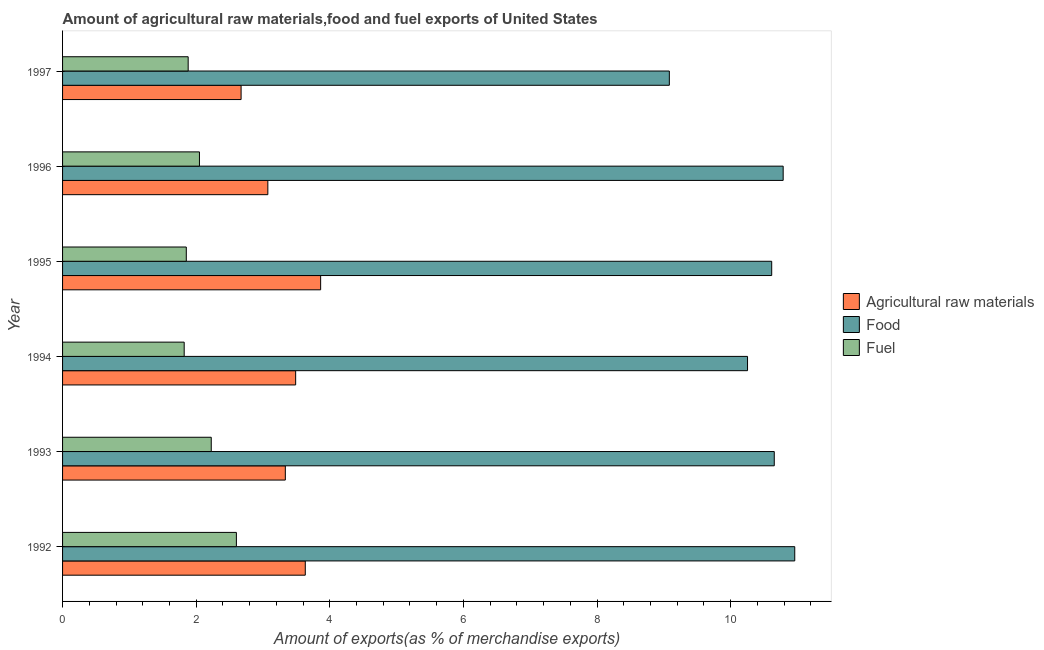How many different coloured bars are there?
Keep it short and to the point. 3. How many bars are there on the 6th tick from the bottom?
Your answer should be compact. 3. What is the percentage of food exports in 1995?
Your response must be concise. 10.61. Across all years, what is the maximum percentage of food exports?
Offer a very short reply. 10.96. Across all years, what is the minimum percentage of food exports?
Keep it short and to the point. 9.08. In which year was the percentage of fuel exports minimum?
Provide a short and direct response. 1994. What is the total percentage of food exports in the graph?
Offer a terse response. 62.35. What is the difference between the percentage of raw materials exports in 1996 and that in 1997?
Make the answer very short. 0.4. What is the difference between the percentage of fuel exports in 1997 and the percentage of raw materials exports in 1992?
Your answer should be very brief. -1.75. What is the average percentage of fuel exports per year?
Give a very brief answer. 2.07. In the year 1994, what is the difference between the percentage of raw materials exports and percentage of food exports?
Make the answer very short. -6.76. What is the ratio of the percentage of fuel exports in 1994 to that in 1996?
Your answer should be compact. 0.89. What is the difference between the highest and the second highest percentage of food exports?
Provide a short and direct response. 0.17. What is the difference between the highest and the lowest percentage of fuel exports?
Provide a succinct answer. 0.78. What does the 2nd bar from the top in 1995 represents?
Ensure brevity in your answer.  Food. What does the 2nd bar from the bottom in 1997 represents?
Offer a terse response. Food. How many years are there in the graph?
Your answer should be compact. 6. Are the values on the major ticks of X-axis written in scientific E-notation?
Offer a terse response. No. Does the graph contain any zero values?
Give a very brief answer. No. How many legend labels are there?
Make the answer very short. 3. What is the title of the graph?
Offer a terse response. Amount of agricultural raw materials,food and fuel exports of United States. What is the label or title of the X-axis?
Your answer should be compact. Amount of exports(as % of merchandise exports). What is the label or title of the Y-axis?
Ensure brevity in your answer.  Year. What is the Amount of exports(as % of merchandise exports) in Agricultural raw materials in 1992?
Your response must be concise. 3.63. What is the Amount of exports(as % of merchandise exports) in Food in 1992?
Keep it short and to the point. 10.96. What is the Amount of exports(as % of merchandise exports) in Fuel in 1992?
Your response must be concise. 2.6. What is the Amount of exports(as % of merchandise exports) in Agricultural raw materials in 1993?
Your response must be concise. 3.33. What is the Amount of exports(as % of merchandise exports) of Food in 1993?
Provide a succinct answer. 10.65. What is the Amount of exports(as % of merchandise exports) of Fuel in 1993?
Your response must be concise. 2.23. What is the Amount of exports(as % of merchandise exports) of Agricultural raw materials in 1994?
Provide a short and direct response. 3.49. What is the Amount of exports(as % of merchandise exports) of Food in 1994?
Provide a succinct answer. 10.25. What is the Amount of exports(as % of merchandise exports) of Fuel in 1994?
Give a very brief answer. 1.82. What is the Amount of exports(as % of merchandise exports) in Agricultural raw materials in 1995?
Your response must be concise. 3.86. What is the Amount of exports(as % of merchandise exports) in Food in 1995?
Give a very brief answer. 10.61. What is the Amount of exports(as % of merchandise exports) of Fuel in 1995?
Provide a short and direct response. 1.85. What is the Amount of exports(as % of merchandise exports) of Agricultural raw materials in 1996?
Your answer should be compact. 3.07. What is the Amount of exports(as % of merchandise exports) of Food in 1996?
Your answer should be compact. 10.79. What is the Amount of exports(as % of merchandise exports) of Fuel in 1996?
Offer a very short reply. 2.05. What is the Amount of exports(as % of merchandise exports) of Agricultural raw materials in 1997?
Your answer should be compact. 2.67. What is the Amount of exports(as % of merchandise exports) in Food in 1997?
Your answer should be very brief. 9.08. What is the Amount of exports(as % of merchandise exports) of Fuel in 1997?
Your answer should be very brief. 1.88. Across all years, what is the maximum Amount of exports(as % of merchandise exports) of Agricultural raw materials?
Offer a terse response. 3.86. Across all years, what is the maximum Amount of exports(as % of merchandise exports) in Food?
Make the answer very short. 10.96. Across all years, what is the maximum Amount of exports(as % of merchandise exports) of Fuel?
Provide a succinct answer. 2.6. Across all years, what is the minimum Amount of exports(as % of merchandise exports) of Agricultural raw materials?
Your answer should be very brief. 2.67. Across all years, what is the minimum Amount of exports(as % of merchandise exports) in Food?
Your answer should be very brief. 9.08. Across all years, what is the minimum Amount of exports(as % of merchandise exports) in Fuel?
Your answer should be compact. 1.82. What is the total Amount of exports(as % of merchandise exports) of Agricultural raw materials in the graph?
Give a very brief answer. 20.06. What is the total Amount of exports(as % of merchandise exports) of Food in the graph?
Offer a very short reply. 62.35. What is the total Amount of exports(as % of merchandise exports) in Fuel in the graph?
Your answer should be compact. 12.43. What is the difference between the Amount of exports(as % of merchandise exports) of Agricultural raw materials in 1992 and that in 1993?
Provide a short and direct response. 0.3. What is the difference between the Amount of exports(as % of merchandise exports) of Food in 1992 and that in 1993?
Keep it short and to the point. 0.31. What is the difference between the Amount of exports(as % of merchandise exports) of Fuel in 1992 and that in 1993?
Your answer should be very brief. 0.38. What is the difference between the Amount of exports(as % of merchandise exports) of Agricultural raw materials in 1992 and that in 1994?
Make the answer very short. 0.14. What is the difference between the Amount of exports(as % of merchandise exports) of Food in 1992 and that in 1994?
Your response must be concise. 0.71. What is the difference between the Amount of exports(as % of merchandise exports) in Fuel in 1992 and that in 1994?
Provide a succinct answer. 0.78. What is the difference between the Amount of exports(as % of merchandise exports) of Agricultural raw materials in 1992 and that in 1995?
Make the answer very short. -0.23. What is the difference between the Amount of exports(as % of merchandise exports) in Food in 1992 and that in 1995?
Give a very brief answer. 0.34. What is the difference between the Amount of exports(as % of merchandise exports) of Fuel in 1992 and that in 1995?
Offer a terse response. 0.75. What is the difference between the Amount of exports(as % of merchandise exports) in Agricultural raw materials in 1992 and that in 1996?
Provide a succinct answer. 0.56. What is the difference between the Amount of exports(as % of merchandise exports) of Food in 1992 and that in 1996?
Offer a terse response. 0.17. What is the difference between the Amount of exports(as % of merchandise exports) of Fuel in 1992 and that in 1996?
Ensure brevity in your answer.  0.55. What is the difference between the Amount of exports(as % of merchandise exports) of Agricultural raw materials in 1992 and that in 1997?
Your answer should be very brief. 0.96. What is the difference between the Amount of exports(as % of merchandise exports) in Food in 1992 and that in 1997?
Make the answer very short. 1.88. What is the difference between the Amount of exports(as % of merchandise exports) of Fuel in 1992 and that in 1997?
Give a very brief answer. 0.72. What is the difference between the Amount of exports(as % of merchandise exports) of Agricultural raw materials in 1993 and that in 1994?
Offer a very short reply. -0.15. What is the difference between the Amount of exports(as % of merchandise exports) in Food in 1993 and that in 1994?
Your answer should be compact. 0.4. What is the difference between the Amount of exports(as % of merchandise exports) in Fuel in 1993 and that in 1994?
Offer a terse response. 0.41. What is the difference between the Amount of exports(as % of merchandise exports) in Agricultural raw materials in 1993 and that in 1995?
Your response must be concise. -0.53. What is the difference between the Amount of exports(as % of merchandise exports) in Food in 1993 and that in 1995?
Make the answer very short. 0.04. What is the difference between the Amount of exports(as % of merchandise exports) in Fuel in 1993 and that in 1995?
Provide a short and direct response. 0.37. What is the difference between the Amount of exports(as % of merchandise exports) of Agricultural raw materials in 1993 and that in 1996?
Your answer should be very brief. 0.26. What is the difference between the Amount of exports(as % of merchandise exports) in Food in 1993 and that in 1996?
Keep it short and to the point. -0.13. What is the difference between the Amount of exports(as % of merchandise exports) of Fuel in 1993 and that in 1996?
Provide a succinct answer. 0.18. What is the difference between the Amount of exports(as % of merchandise exports) of Agricultural raw materials in 1993 and that in 1997?
Keep it short and to the point. 0.66. What is the difference between the Amount of exports(as % of merchandise exports) in Food in 1993 and that in 1997?
Provide a succinct answer. 1.57. What is the difference between the Amount of exports(as % of merchandise exports) in Fuel in 1993 and that in 1997?
Your answer should be very brief. 0.35. What is the difference between the Amount of exports(as % of merchandise exports) in Agricultural raw materials in 1994 and that in 1995?
Keep it short and to the point. -0.37. What is the difference between the Amount of exports(as % of merchandise exports) of Food in 1994 and that in 1995?
Offer a terse response. -0.36. What is the difference between the Amount of exports(as % of merchandise exports) in Fuel in 1994 and that in 1995?
Keep it short and to the point. -0.03. What is the difference between the Amount of exports(as % of merchandise exports) in Agricultural raw materials in 1994 and that in 1996?
Your answer should be compact. 0.42. What is the difference between the Amount of exports(as % of merchandise exports) in Food in 1994 and that in 1996?
Provide a succinct answer. -0.53. What is the difference between the Amount of exports(as % of merchandise exports) in Fuel in 1994 and that in 1996?
Offer a terse response. -0.23. What is the difference between the Amount of exports(as % of merchandise exports) in Agricultural raw materials in 1994 and that in 1997?
Provide a succinct answer. 0.82. What is the difference between the Amount of exports(as % of merchandise exports) of Food in 1994 and that in 1997?
Provide a short and direct response. 1.17. What is the difference between the Amount of exports(as % of merchandise exports) in Fuel in 1994 and that in 1997?
Provide a succinct answer. -0.06. What is the difference between the Amount of exports(as % of merchandise exports) of Agricultural raw materials in 1995 and that in 1996?
Give a very brief answer. 0.79. What is the difference between the Amount of exports(as % of merchandise exports) of Food in 1995 and that in 1996?
Your answer should be very brief. -0.17. What is the difference between the Amount of exports(as % of merchandise exports) in Fuel in 1995 and that in 1996?
Your answer should be very brief. -0.2. What is the difference between the Amount of exports(as % of merchandise exports) in Agricultural raw materials in 1995 and that in 1997?
Your answer should be compact. 1.19. What is the difference between the Amount of exports(as % of merchandise exports) in Food in 1995 and that in 1997?
Your answer should be very brief. 1.53. What is the difference between the Amount of exports(as % of merchandise exports) in Fuel in 1995 and that in 1997?
Offer a very short reply. -0.03. What is the difference between the Amount of exports(as % of merchandise exports) in Agricultural raw materials in 1996 and that in 1997?
Your answer should be very brief. 0.4. What is the difference between the Amount of exports(as % of merchandise exports) in Food in 1996 and that in 1997?
Offer a terse response. 1.7. What is the difference between the Amount of exports(as % of merchandise exports) of Fuel in 1996 and that in 1997?
Provide a succinct answer. 0.17. What is the difference between the Amount of exports(as % of merchandise exports) in Agricultural raw materials in 1992 and the Amount of exports(as % of merchandise exports) in Food in 1993?
Ensure brevity in your answer.  -7.02. What is the difference between the Amount of exports(as % of merchandise exports) of Agricultural raw materials in 1992 and the Amount of exports(as % of merchandise exports) of Fuel in 1993?
Your answer should be compact. 1.41. What is the difference between the Amount of exports(as % of merchandise exports) of Food in 1992 and the Amount of exports(as % of merchandise exports) of Fuel in 1993?
Your answer should be very brief. 8.73. What is the difference between the Amount of exports(as % of merchandise exports) of Agricultural raw materials in 1992 and the Amount of exports(as % of merchandise exports) of Food in 1994?
Ensure brevity in your answer.  -6.62. What is the difference between the Amount of exports(as % of merchandise exports) of Agricultural raw materials in 1992 and the Amount of exports(as % of merchandise exports) of Fuel in 1994?
Ensure brevity in your answer.  1.81. What is the difference between the Amount of exports(as % of merchandise exports) in Food in 1992 and the Amount of exports(as % of merchandise exports) in Fuel in 1994?
Offer a very short reply. 9.14. What is the difference between the Amount of exports(as % of merchandise exports) in Agricultural raw materials in 1992 and the Amount of exports(as % of merchandise exports) in Food in 1995?
Make the answer very short. -6.98. What is the difference between the Amount of exports(as % of merchandise exports) in Agricultural raw materials in 1992 and the Amount of exports(as % of merchandise exports) in Fuel in 1995?
Offer a very short reply. 1.78. What is the difference between the Amount of exports(as % of merchandise exports) in Food in 1992 and the Amount of exports(as % of merchandise exports) in Fuel in 1995?
Your answer should be very brief. 9.11. What is the difference between the Amount of exports(as % of merchandise exports) of Agricultural raw materials in 1992 and the Amount of exports(as % of merchandise exports) of Food in 1996?
Provide a short and direct response. -7.15. What is the difference between the Amount of exports(as % of merchandise exports) in Agricultural raw materials in 1992 and the Amount of exports(as % of merchandise exports) in Fuel in 1996?
Your answer should be compact. 1.58. What is the difference between the Amount of exports(as % of merchandise exports) in Food in 1992 and the Amount of exports(as % of merchandise exports) in Fuel in 1996?
Make the answer very short. 8.91. What is the difference between the Amount of exports(as % of merchandise exports) of Agricultural raw materials in 1992 and the Amount of exports(as % of merchandise exports) of Food in 1997?
Your answer should be compact. -5.45. What is the difference between the Amount of exports(as % of merchandise exports) in Agricultural raw materials in 1992 and the Amount of exports(as % of merchandise exports) in Fuel in 1997?
Offer a very short reply. 1.75. What is the difference between the Amount of exports(as % of merchandise exports) in Food in 1992 and the Amount of exports(as % of merchandise exports) in Fuel in 1997?
Provide a succinct answer. 9.08. What is the difference between the Amount of exports(as % of merchandise exports) in Agricultural raw materials in 1993 and the Amount of exports(as % of merchandise exports) in Food in 1994?
Give a very brief answer. -6.92. What is the difference between the Amount of exports(as % of merchandise exports) of Agricultural raw materials in 1993 and the Amount of exports(as % of merchandise exports) of Fuel in 1994?
Make the answer very short. 1.51. What is the difference between the Amount of exports(as % of merchandise exports) of Food in 1993 and the Amount of exports(as % of merchandise exports) of Fuel in 1994?
Give a very brief answer. 8.83. What is the difference between the Amount of exports(as % of merchandise exports) of Agricultural raw materials in 1993 and the Amount of exports(as % of merchandise exports) of Food in 1995?
Ensure brevity in your answer.  -7.28. What is the difference between the Amount of exports(as % of merchandise exports) of Agricultural raw materials in 1993 and the Amount of exports(as % of merchandise exports) of Fuel in 1995?
Provide a short and direct response. 1.48. What is the difference between the Amount of exports(as % of merchandise exports) of Food in 1993 and the Amount of exports(as % of merchandise exports) of Fuel in 1995?
Offer a very short reply. 8.8. What is the difference between the Amount of exports(as % of merchandise exports) in Agricultural raw materials in 1993 and the Amount of exports(as % of merchandise exports) in Food in 1996?
Your response must be concise. -7.45. What is the difference between the Amount of exports(as % of merchandise exports) in Agricultural raw materials in 1993 and the Amount of exports(as % of merchandise exports) in Fuel in 1996?
Offer a terse response. 1.29. What is the difference between the Amount of exports(as % of merchandise exports) of Food in 1993 and the Amount of exports(as % of merchandise exports) of Fuel in 1996?
Your answer should be compact. 8.6. What is the difference between the Amount of exports(as % of merchandise exports) in Agricultural raw materials in 1993 and the Amount of exports(as % of merchandise exports) in Food in 1997?
Provide a succinct answer. -5.75. What is the difference between the Amount of exports(as % of merchandise exports) of Agricultural raw materials in 1993 and the Amount of exports(as % of merchandise exports) of Fuel in 1997?
Offer a terse response. 1.45. What is the difference between the Amount of exports(as % of merchandise exports) in Food in 1993 and the Amount of exports(as % of merchandise exports) in Fuel in 1997?
Make the answer very short. 8.77. What is the difference between the Amount of exports(as % of merchandise exports) in Agricultural raw materials in 1994 and the Amount of exports(as % of merchandise exports) in Food in 1995?
Provide a short and direct response. -7.13. What is the difference between the Amount of exports(as % of merchandise exports) in Agricultural raw materials in 1994 and the Amount of exports(as % of merchandise exports) in Fuel in 1995?
Provide a succinct answer. 1.64. What is the difference between the Amount of exports(as % of merchandise exports) in Food in 1994 and the Amount of exports(as % of merchandise exports) in Fuel in 1995?
Give a very brief answer. 8.4. What is the difference between the Amount of exports(as % of merchandise exports) in Agricultural raw materials in 1994 and the Amount of exports(as % of merchandise exports) in Food in 1996?
Provide a short and direct response. -7.3. What is the difference between the Amount of exports(as % of merchandise exports) of Agricultural raw materials in 1994 and the Amount of exports(as % of merchandise exports) of Fuel in 1996?
Offer a terse response. 1.44. What is the difference between the Amount of exports(as % of merchandise exports) of Food in 1994 and the Amount of exports(as % of merchandise exports) of Fuel in 1996?
Provide a succinct answer. 8.2. What is the difference between the Amount of exports(as % of merchandise exports) in Agricultural raw materials in 1994 and the Amount of exports(as % of merchandise exports) in Food in 1997?
Give a very brief answer. -5.59. What is the difference between the Amount of exports(as % of merchandise exports) in Agricultural raw materials in 1994 and the Amount of exports(as % of merchandise exports) in Fuel in 1997?
Your answer should be compact. 1.61. What is the difference between the Amount of exports(as % of merchandise exports) in Food in 1994 and the Amount of exports(as % of merchandise exports) in Fuel in 1997?
Give a very brief answer. 8.37. What is the difference between the Amount of exports(as % of merchandise exports) of Agricultural raw materials in 1995 and the Amount of exports(as % of merchandise exports) of Food in 1996?
Provide a short and direct response. -6.92. What is the difference between the Amount of exports(as % of merchandise exports) of Agricultural raw materials in 1995 and the Amount of exports(as % of merchandise exports) of Fuel in 1996?
Offer a terse response. 1.81. What is the difference between the Amount of exports(as % of merchandise exports) of Food in 1995 and the Amount of exports(as % of merchandise exports) of Fuel in 1996?
Give a very brief answer. 8.57. What is the difference between the Amount of exports(as % of merchandise exports) of Agricultural raw materials in 1995 and the Amount of exports(as % of merchandise exports) of Food in 1997?
Offer a terse response. -5.22. What is the difference between the Amount of exports(as % of merchandise exports) in Agricultural raw materials in 1995 and the Amount of exports(as % of merchandise exports) in Fuel in 1997?
Give a very brief answer. 1.98. What is the difference between the Amount of exports(as % of merchandise exports) of Food in 1995 and the Amount of exports(as % of merchandise exports) of Fuel in 1997?
Your answer should be compact. 8.73. What is the difference between the Amount of exports(as % of merchandise exports) of Agricultural raw materials in 1996 and the Amount of exports(as % of merchandise exports) of Food in 1997?
Your answer should be compact. -6.01. What is the difference between the Amount of exports(as % of merchandise exports) in Agricultural raw materials in 1996 and the Amount of exports(as % of merchandise exports) in Fuel in 1997?
Keep it short and to the point. 1.19. What is the difference between the Amount of exports(as % of merchandise exports) in Food in 1996 and the Amount of exports(as % of merchandise exports) in Fuel in 1997?
Your answer should be compact. 8.91. What is the average Amount of exports(as % of merchandise exports) in Agricultural raw materials per year?
Ensure brevity in your answer.  3.34. What is the average Amount of exports(as % of merchandise exports) in Food per year?
Keep it short and to the point. 10.39. What is the average Amount of exports(as % of merchandise exports) of Fuel per year?
Offer a terse response. 2.07. In the year 1992, what is the difference between the Amount of exports(as % of merchandise exports) in Agricultural raw materials and Amount of exports(as % of merchandise exports) in Food?
Your answer should be compact. -7.33. In the year 1992, what is the difference between the Amount of exports(as % of merchandise exports) of Agricultural raw materials and Amount of exports(as % of merchandise exports) of Fuel?
Provide a short and direct response. 1.03. In the year 1992, what is the difference between the Amount of exports(as % of merchandise exports) of Food and Amount of exports(as % of merchandise exports) of Fuel?
Your answer should be compact. 8.36. In the year 1993, what is the difference between the Amount of exports(as % of merchandise exports) in Agricultural raw materials and Amount of exports(as % of merchandise exports) in Food?
Your answer should be compact. -7.32. In the year 1993, what is the difference between the Amount of exports(as % of merchandise exports) of Agricultural raw materials and Amount of exports(as % of merchandise exports) of Fuel?
Ensure brevity in your answer.  1.11. In the year 1993, what is the difference between the Amount of exports(as % of merchandise exports) of Food and Amount of exports(as % of merchandise exports) of Fuel?
Give a very brief answer. 8.43. In the year 1994, what is the difference between the Amount of exports(as % of merchandise exports) in Agricultural raw materials and Amount of exports(as % of merchandise exports) in Food?
Offer a terse response. -6.76. In the year 1994, what is the difference between the Amount of exports(as % of merchandise exports) in Agricultural raw materials and Amount of exports(as % of merchandise exports) in Fuel?
Keep it short and to the point. 1.67. In the year 1994, what is the difference between the Amount of exports(as % of merchandise exports) in Food and Amount of exports(as % of merchandise exports) in Fuel?
Make the answer very short. 8.43. In the year 1995, what is the difference between the Amount of exports(as % of merchandise exports) of Agricultural raw materials and Amount of exports(as % of merchandise exports) of Food?
Your response must be concise. -6.75. In the year 1995, what is the difference between the Amount of exports(as % of merchandise exports) of Agricultural raw materials and Amount of exports(as % of merchandise exports) of Fuel?
Offer a very short reply. 2.01. In the year 1995, what is the difference between the Amount of exports(as % of merchandise exports) of Food and Amount of exports(as % of merchandise exports) of Fuel?
Your response must be concise. 8.76. In the year 1996, what is the difference between the Amount of exports(as % of merchandise exports) of Agricultural raw materials and Amount of exports(as % of merchandise exports) of Food?
Provide a succinct answer. -7.71. In the year 1996, what is the difference between the Amount of exports(as % of merchandise exports) of Agricultural raw materials and Amount of exports(as % of merchandise exports) of Fuel?
Your answer should be compact. 1.02. In the year 1996, what is the difference between the Amount of exports(as % of merchandise exports) of Food and Amount of exports(as % of merchandise exports) of Fuel?
Give a very brief answer. 8.74. In the year 1997, what is the difference between the Amount of exports(as % of merchandise exports) in Agricultural raw materials and Amount of exports(as % of merchandise exports) in Food?
Your answer should be compact. -6.41. In the year 1997, what is the difference between the Amount of exports(as % of merchandise exports) of Agricultural raw materials and Amount of exports(as % of merchandise exports) of Fuel?
Provide a short and direct response. 0.79. In the year 1997, what is the difference between the Amount of exports(as % of merchandise exports) in Food and Amount of exports(as % of merchandise exports) in Fuel?
Keep it short and to the point. 7.2. What is the ratio of the Amount of exports(as % of merchandise exports) in Agricultural raw materials in 1992 to that in 1993?
Your answer should be compact. 1.09. What is the ratio of the Amount of exports(as % of merchandise exports) of Food in 1992 to that in 1993?
Your answer should be very brief. 1.03. What is the ratio of the Amount of exports(as % of merchandise exports) in Fuel in 1992 to that in 1993?
Your response must be concise. 1.17. What is the ratio of the Amount of exports(as % of merchandise exports) of Agricultural raw materials in 1992 to that in 1994?
Offer a terse response. 1.04. What is the ratio of the Amount of exports(as % of merchandise exports) in Food in 1992 to that in 1994?
Your answer should be compact. 1.07. What is the ratio of the Amount of exports(as % of merchandise exports) of Fuel in 1992 to that in 1994?
Make the answer very short. 1.43. What is the ratio of the Amount of exports(as % of merchandise exports) of Agricultural raw materials in 1992 to that in 1995?
Your answer should be compact. 0.94. What is the ratio of the Amount of exports(as % of merchandise exports) of Food in 1992 to that in 1995?
Provide a short and direct response. 1.03. What is the ratio of the Amount of exports(as % of merchandise exports) of Fuel in 1992 to that in 1995?
Provide a short and direct response. 1.4. What is the ratio of the Amount of exports(as % of merchandise exports) in Agricultural raw materials in 1992 to that in 1996?
Give a very brief answer. 1.18. What is the ratio of the Amount of exports(as % of merchandise exports) of Food in 1992 to that in 1996?
Offer a terse response. 1.02. What is the ratio of the Amount of exports(as % of merchandise exports) in Fuel in 1992 to that in 1996?
Offer a very short reply. 1.27. What is the ratio of the Amount of exports(as % of merchandise exports) of Agricultural raw materials in 1992 to that in 1997?
Ensure brevity in your answer.  1.36. What is the ratio of the Amount of exports(as % of merchandise exports) in Food in 1992 to that in 1997?
Your answer should be compact. 1.21. What is the ratio of the Amount of exports(as % of merchandise exports) of Fuel in 1992 to that in 1997?
Offer a very short reply. 1.38. What is the ratio of the Amount of exports(as % of merchandise exports) of Agricultural raw materials in 1993 to that in 1994?
Make the answer very short. 0.96. What is the ratio of the Amount of exports(as % of merchandise exports) of Food in 1993 to that in 1994?
Provide a succinct answer. 1.04. What is the ratio of the Amount of exports(as % of merchandise exports) in Fuel in 1993 to that in 1994?
Your answer should be very brief. 1.22. What is the ratio of the Amount of exports(as % of merchandise exports) in Agricultural raw materials in 1993 to that in 1995?
Offer a very short reply. 0.86. What is the ratio of the Amount of exports(as % of merchandise exports) in Food in 1993 to that in 1995?
Keep it short and to the point. 1. What is the ratio of the Amount of exports(as % of merchandise exports) of Fuel in 1993 to that in 1995?
Provide a short and direct response. 1.2. What is the ratio of the Amount of exports(as % of merchandise exports) in Agricultural raw materials in 1993 to that in 1996?
Your response must be concise. 1.09. What is the ratio of the Amount of exports(as % of merchandise exports) in Fuel in 1993 to that in 1996?
Ensure brevity in your answer.  1.09. What is the ratio of the Amount of exports(as % of merchandise exports) of Agricultural raw materials in 1993 to that in 1997?
Give a very brief answer. 1.25. What is the ratio of the Amount of exports(as % of merchandise exports) of Food in 1993 to that in 1997?
Your answer should be compact. 1.17. What is the ratio of the Amount of exports(as % of merchandise exports) of Fuel in 1993 to that in 1997?
Offer a terse response. 1.18. What is the ratio of the Amount of exports(as % of merchandise exports) of Agricultural raw materials in 1994 to that in 1995?
Provide a short and direct response. 0.9. What is the ratio of the Amount of exports(as % of merchandise exports) in Food in 1994 to that in 1995?
Your response must be concise. 0.97. What is the ratio of the Amount of exports(as % of merchandise exports) of Fuel in 1994 to that in 1995?
Offer a terse response. 0.98. What is the ratio of the Amount of exports(as % of merchandise exports) in Agricultural raw materials in 1994 to that in 1996?
Give a very brief answer. 1.14. What is the ratio of the Amount of exports(as % of merchandise exports) in Food in 1994 to that in 1996?
Provide a succinct answer. 0.95. What is the ratio of the Amount of exports(as % of merchandise exports) of Fuel in 1994 to that in 1996?
Your answer should be compact. 0.89. What is the ratio of the Amount of exports(as % of merchandise exports) of Agricultural raw materials in 1994 to that in 1997?
Provide a succinct answer. 1.31. What is the ratio of the Amount of exports(as % of merchandise exports) in Food in 1994 to that in 1997?
Give a very brief answer. 1.13. What is the ratio of the Amount of exports(as % of merchandise exports) in Fuel in 1994 to that in 1997?
Your answer should be compact. 0.97. What is the ratio of the Amount of exports(as % of merchandise exports) in Agricultural raw materials in 1995 to that in 1996?
Offer a very short reply. 1.26. What is the ratio of the Amount of exports(as % of merchandise exports) of Food in 1995 to that in 1996?
Your answer should be compact. 0.98. What is the ratio of the Amount of exports(as % of merchandise exports) in Fuel in 1995 to that in 1996?
Provide a succinct answer. 0.9. What is the ratio of the Amount of exports(as % of merchandise exports) of Agricultural raw materials in 1995 to that in 1997?
Keep it short and to the point. 1.45. What is the ratio of the Amount of exports(as % of merchandise exports) of Food in 1995 to that in 1997?
Your answer should be very brief. 1.17. What is the ratio of the Amount of exports(as % of merchandise exports) in Fuel in 1995 to that in 1997?
Keep it short and to the point. 0.99. What is the ratio of the Amount of exports(as % of merchandise exports) in Agricultural raw materials in 1996 to that in 1997?
Offer a very short reply. 1.15. What is the ratio of the Amount of exports(as % of merchandise exports) in Food in 1996 to that in 1997?
Your answer should be compact. 1.19. What is the ratio of the Amount of exports(as % of merchandise exports) of Fuel in 1996 to that in 1997?
Provide a succinct answer. 1.09. What is the difference between the highest and the second highest Amount of exports(as % of merchandise exports) in Agricultural raw materials?
Your answer should be very brief. 0.23. What is the difference between the highest and the second highest Amount of exports(as % of merchandise exports) of Food?
Ensure brevity in your answer.  0.17. What is the difference between the highest and the second highest Amount of exports(as % of merchandise exports) of Fuel?
Your answer should be very brief. 0.38. What is the difference between the highest and the lowest Amount of exports(as % of merchandise exports) of Agricultural raw materials?
Offer a terse response. 1.19. What is the difference between the highest and the lowest Amount of exports(as % of merchandise exports) in Food?
Provide a short and direct response. 1.88. What is the difference between the highest and the lowest Amount of exports(as % of merchandise exports) of Fuel?
Keep it short and to the point. 0.78. 